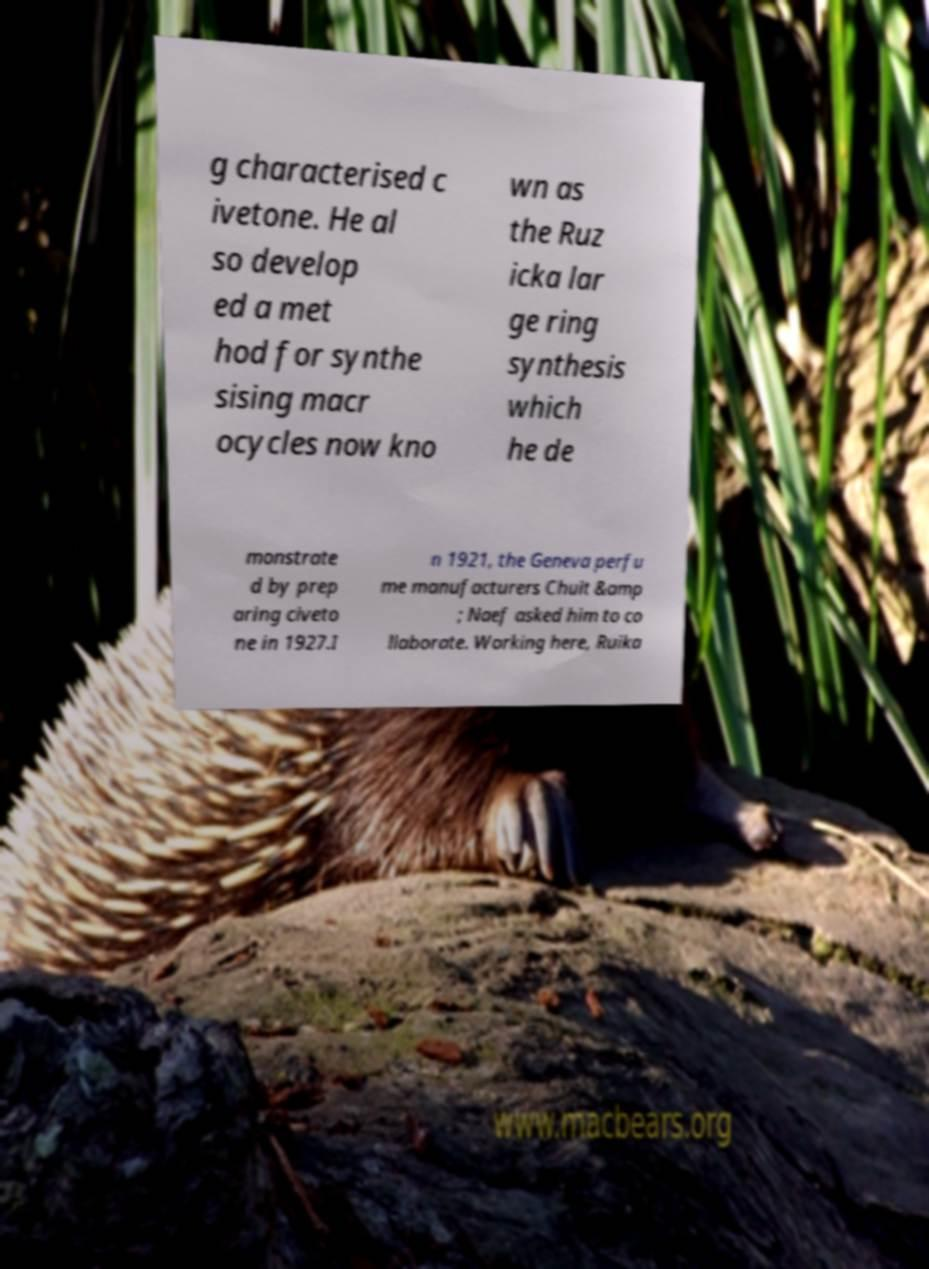Can you accurately transcribe the text from the provided image for me? g characterised c ivetone. He al so develop ed a met hod for synthe sising macr ocycles now kno wn as the Ruz icka lar ge ring synthesis which he de monstrate d by prep aring civeto ne in 1927.I n 1921, the Geneva perfu me manufacturers Chuit &amp ; Naef asked him to co llaborate. Working here, Ruika 